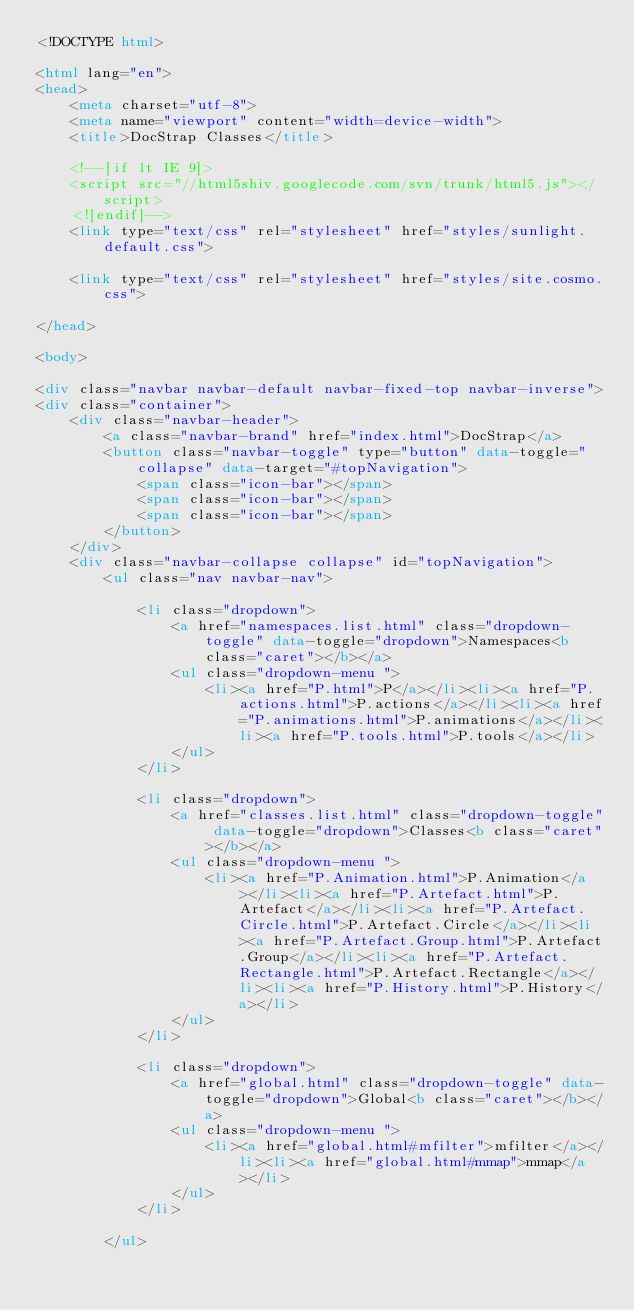Convert code to text. <code><loc_0><loc_0><loc_500><loc_500><_HTML_><!DOCTYPE html>

<html lang="en">
<head>
	<meta charset="utf-8">
	<meta name="viewport" content="width=device-width">
	<title>DocStrap Classes</title>

	<!--[if lt IE 9]>
	<script src="//html5shiv.googlecode.com/svn/trunk/html5.js"></script>
	<![endif]-->
	<link type="text/css" rel="stylesheet" href="styles/sunlight.default.css">

	<link type="text/css" rel="stylesheet" href="styles/site.cosmo.css">

</head>

<body>

<div class="navbar navbar-default navbar-fixed-top navbar-inverse">
<div class="container">
	<div class="navbar-header">
		<a class="navbar-brand" href="index.html">DocStrap</a>
		<button class="navbar-toggle" type="button" data-toggle="collapse" data-target="#topNavigation">
			<span class="icon-bar"></span>
			<span class="icon-bar"></span>
			<span class="icon-bar"></span>
        </button>
	</div>
	<div class="navbar-collapse collapse" id="topNavigation">
		<ul class="nav navbar-nav">
			
			<li class="dropdown">
				<a href="namespaces.list.html" class="dropdown-toggle" data-toggle="dropdown">Namespaces<b class="caret"></b></a>
				<ul class="dropdown-menu ">
					<li><a href="P.html">P</a></li><li><a href="P.actions.html">P.actions</a></li><li><a href="P.animations.html">P.animations</a></li><li><a href="P.tools.html">P.tools</a></li>
				</ul>
			</li>
			
			<li class="dropdown">
				<a href="classes.list.html" class="dropdown-toggle" data-toggle="dropdown">Classes<b class="caret"></b></a>
				<ul class="dropdown-menu ">
					<li><a href="P.Animation.html">P.Animation</a></li><li><a href="P.Artefact.html">P.Artefact</a></li><li><a href="P.Artefact.Circle.html">P.Artefact.Circle</a></li><li><a href="P.Artefact.Group.html">P.Artefact.Group</a></li><li><a href="P.Artefact.Rectangle.html">P.Artefact.Rectangle</a></li><li><a href="P.History.html">P.History</a></li>
				</ul>
			</li>
			
			<li class="dropdown">
				<a href="global.html" class="dropdown-toggle" data-toggle="dropdown">Global<b class="caret"></b></a>
				<ul class="dropdown-menu ">
					<li><a href="global.html#mfilter">mfilter</a></li><li><a href="global.html#mmap">mmap</a></li>
				</ul>
			</li>
			
		</ul></code> 